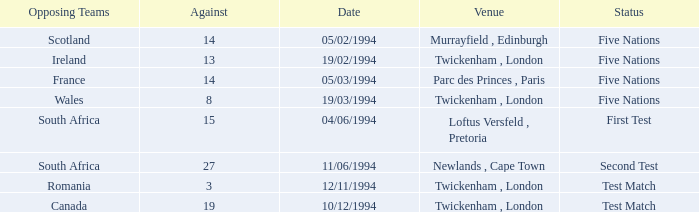Which venue has more than 19 against? Newlands , Cape Town. 